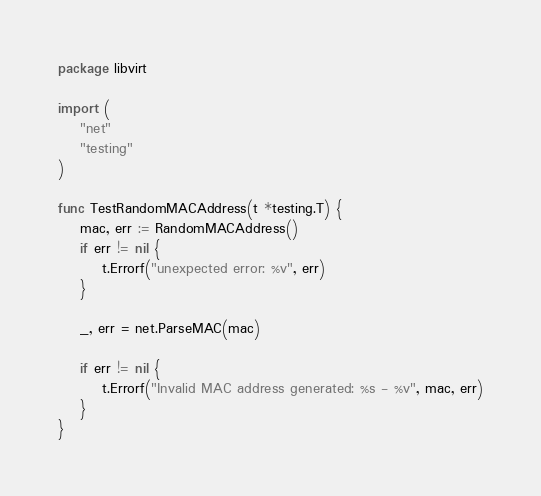Convert code to text. <code><loc_0><loc_0><loc_500><loc_500><_Go_>package libvirt

import (
	"net"
	"testing"
)

func TestRandomMACAddress(t *testing.T) {
	mac, err := RandomMACAddress()
	if err != nil {
		t.Errorf("unexpected error: %v", err)
	}

	_, err = net.ParseMAC(mac)

	if err != nil {
		t.Errorf("Invalid MAC address generated: %s - %v", mac, err)
	}
}
</code> 